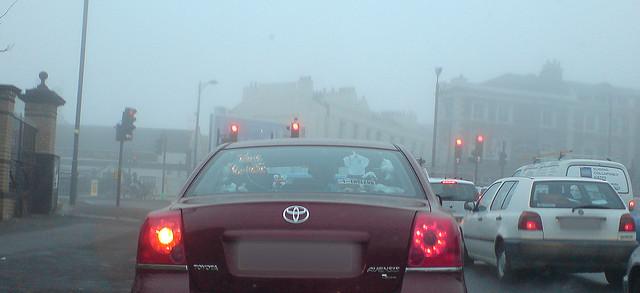How is the traffic?
Short answer required. Heavy. What is the make of the car in red?
Be succinct. Toyota. Is this a clear day?
Give a very brief answer. No. 